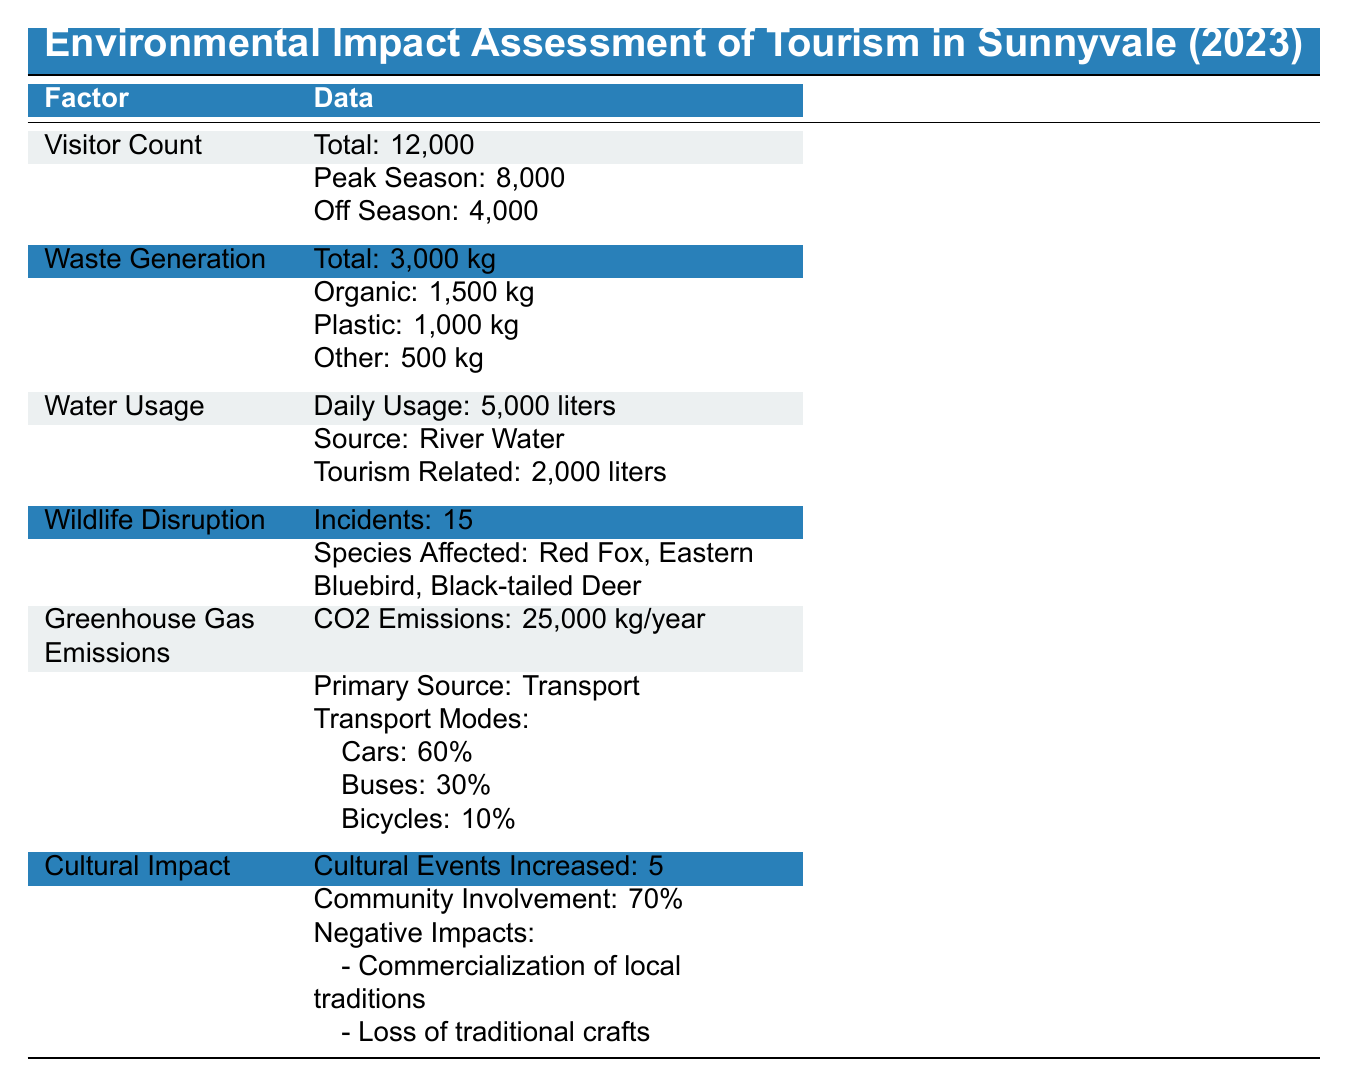What is the total number of visitors in Sunnyvale? The table states that the total visitor count is 12,000, which is the first data point listed under Visitor Count.
Answer: 12,000 How many visitors were there in peak season? According to the table, 8,000 visitors visited during the peak season, as indicated directly under Visitor Count.
Answer: 8,000 What percentage of the waste generated is organic? The total waste generated is 3,000 kg, with 1,500 kg being organic. To find the percentage, use the formula (Organic Waste / Total Waste) * 100 = (1500 / 3000) * 100 = 50%.
Answer: 50% Are there more incidents reported for wildlife disruption than cultural impacts? The table states that 15 incidents of wildlife disruption were reported, while there are 5 cultural events increased, indicating a factual comparison. Since 15 is greater than 5, it confirms that there are more incidents reported for wildlife disruption.
Answer: Yes How much is the total waste generated from plastic and other types combined? The plastic waste is 1,000 kg, and other waste is 500 kg. To find the total, sum these two values: 1,000 kg + 500 kg = 1,500 kg. This calculates the combined amounts of plastic and other waste.
Answer: 1,500 kg What is the primary source of greenhouse gas emissions according to the data? The table lists the primary source of greenhouse gas emissions as transport under the Greenhouse Gas Emissions section.
Answer: Transport Which species were affected by wildlife disruption? The table lists three species affected: Red Fox, Eastern Bluebird, and Black-tailed Deer under the Wildlife Disruption section.
Answer: Red Fox, Eastern Bluebird, Black-tailed Deer What is the average daily water usage in liters? The table provides a daily water usage of 5,000 liters as a specific data point, so there's no calculation needed; it's stated directly.
Answer: 5,000 liters What is the ratio of tourists using cars compared to those using bicycles? The table states that 60% of tourists use cars and 10% use bicycles. The ratio of car users to bicycle users is 60:10, which simplifies to 6:1.
Answer: 6:1 